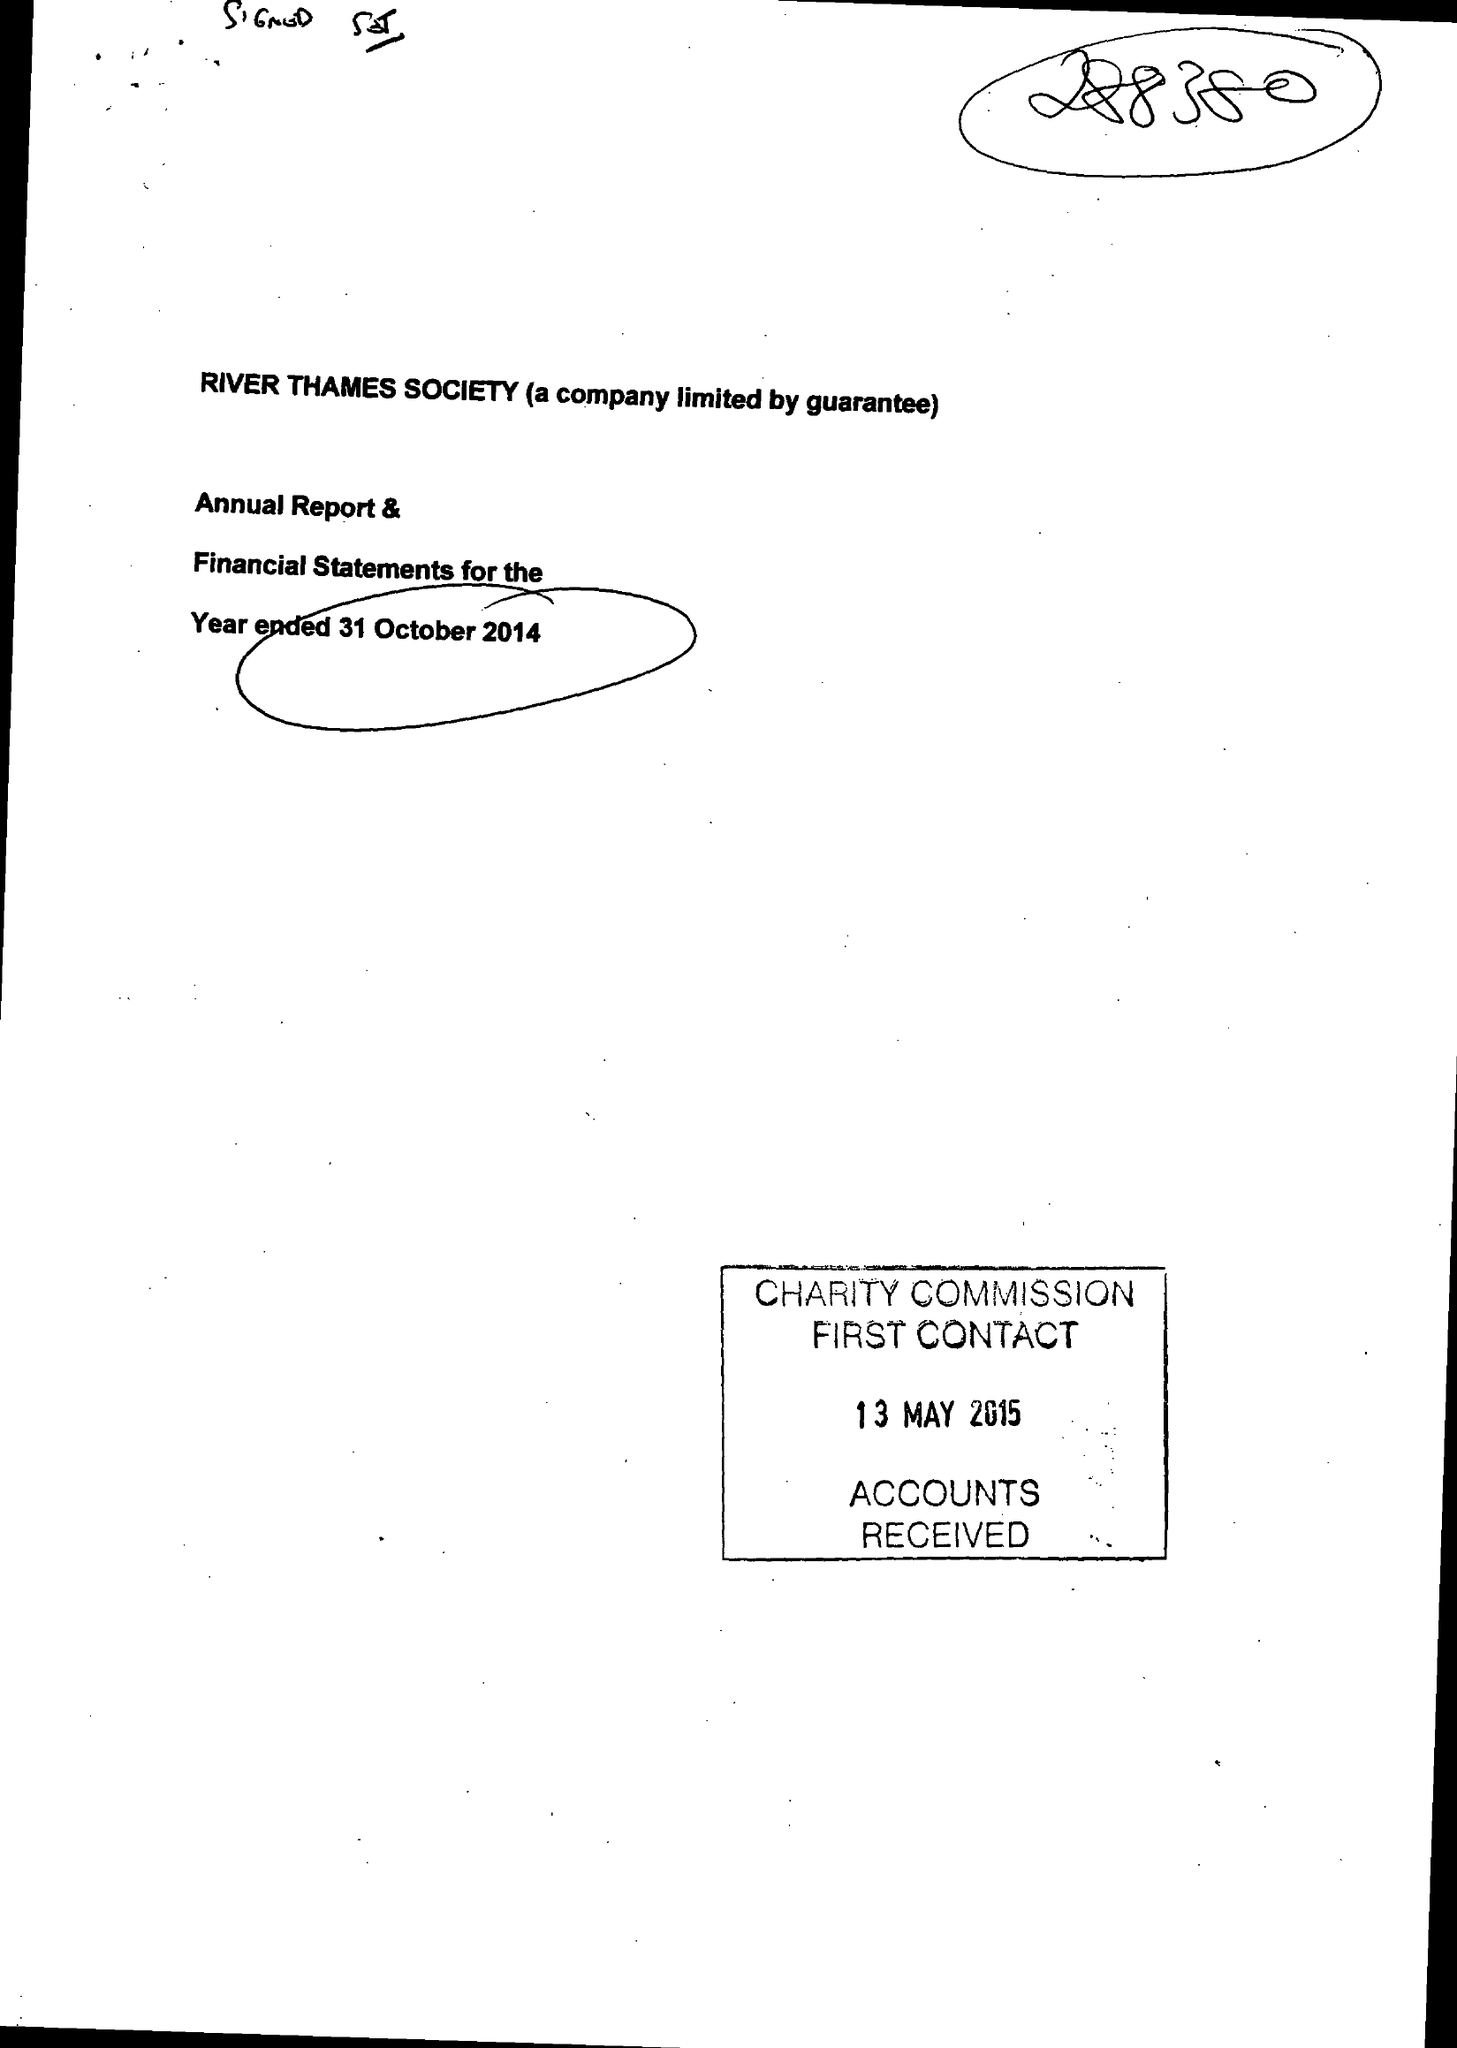What is the value for the address__post_town?
Answer the question using a single word or phrase. WINDSOR 